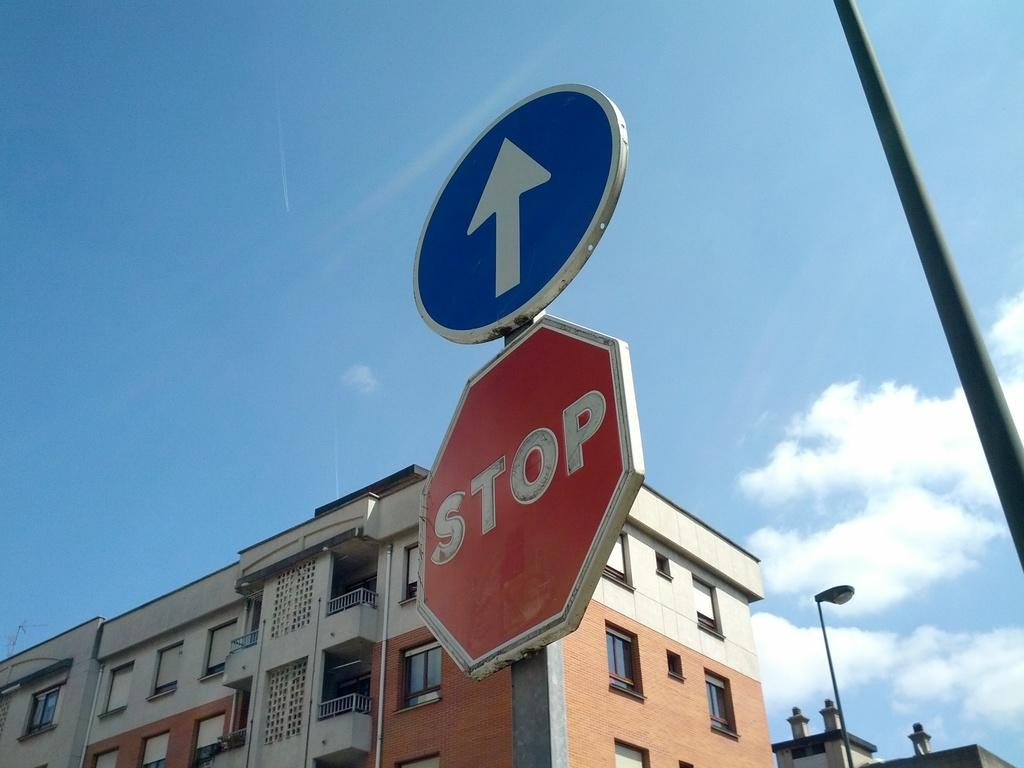Provide a one-sentence caption for the provided image. A sign with an arrow is above a stop sign. 